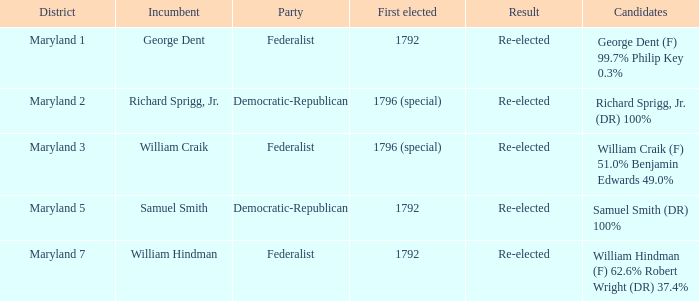In the case where samuel smith is the incumbent, what is his affiliated party? Democratic-Republican. 